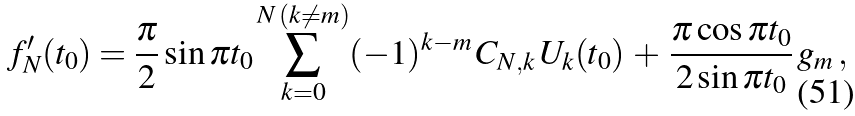Convert formula to latex. <formula><loc_0><loc_0><loc_500><loc_500>f _ { N } ^ { \prime } ( t _ { 0 } ) = \frac { \pi } { 2 } \sin \pi t _ { 0 } \sum _ { k = 0 } ^ { N \, ( k \neq m ) } ( - 1 ) ^ { k - m } \, C _ { N , k } \, U _ { k } ( t _ { 0 } ) \, + \, \frac { \pi \cos \pi t _ { 0 } } { 2 \sin \pi t _ { 0 } } \, g _ { m } \, ,</formula> 